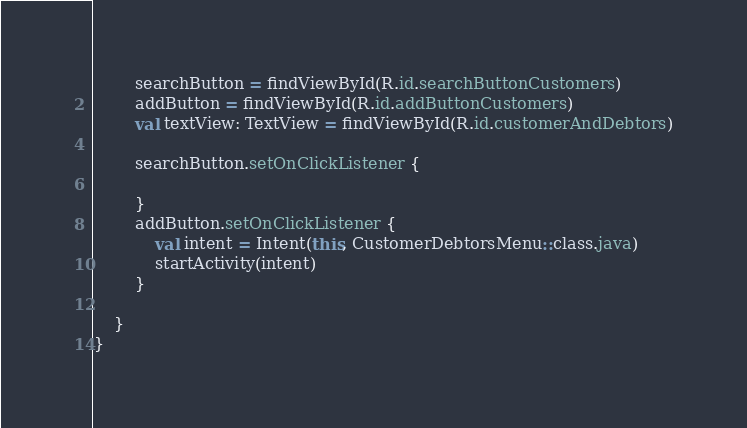Convert code to text. <code><loc_0><loc_0><loc_500><loc_500><_Kotlin_>
        searchButton = findViewById(R.id.searchButtonCustomers)
        addButton = findViewById(R.id.addButtonCustomers)
        val textView: TextView = findViewById(R.id.customerAndDebtors)

        searchButton.setOnClickListener {

        }
        addButton.setOnClickListener {
            val intent = Intent(this, CustomerDebtorsMenu::class.java)
            startActivity(intent)
        }

    }
}</code> 